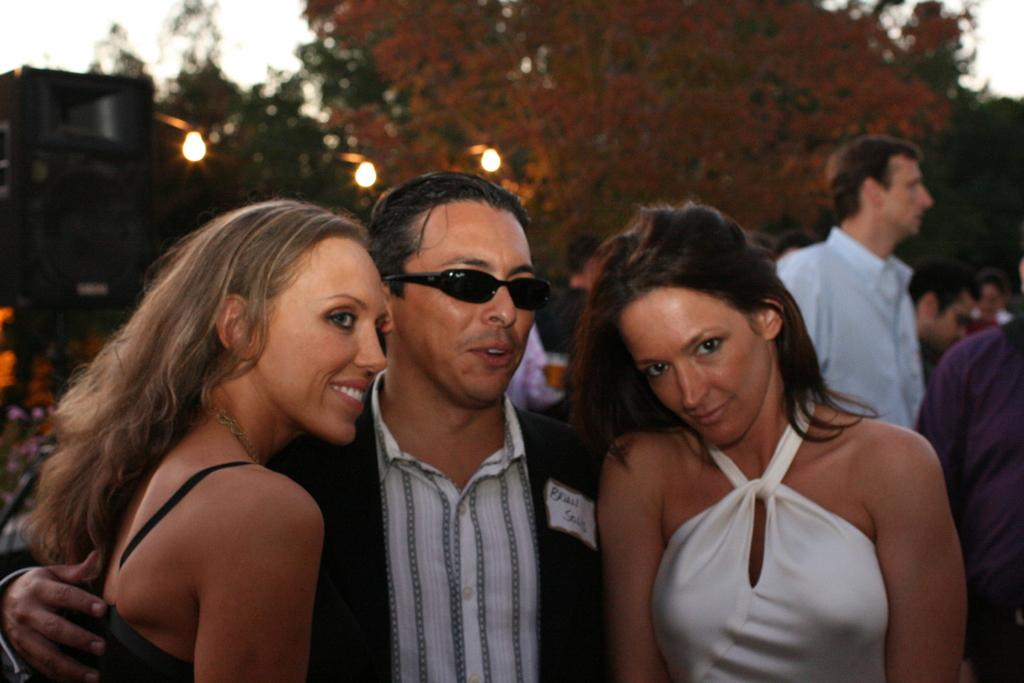What is happening in the center of the image? There are persons standing in the center of the image. Can you describe the scene in the background? There are persons, trees, a building, the sky, and lights visible in the background of the image. How many groups of people can be seen in the image? There are two groups of people: one in the center and one in the background. What type of structure is visible in the background? There is a building in the background of the image. What type of rice is being served to the persons in the image? There is no rice present in the image; it features persons standing in the center and a background scene. What type of treatment is being administered to the persons in the image? There is no indication of any treatment being administered to the persons in the image. 